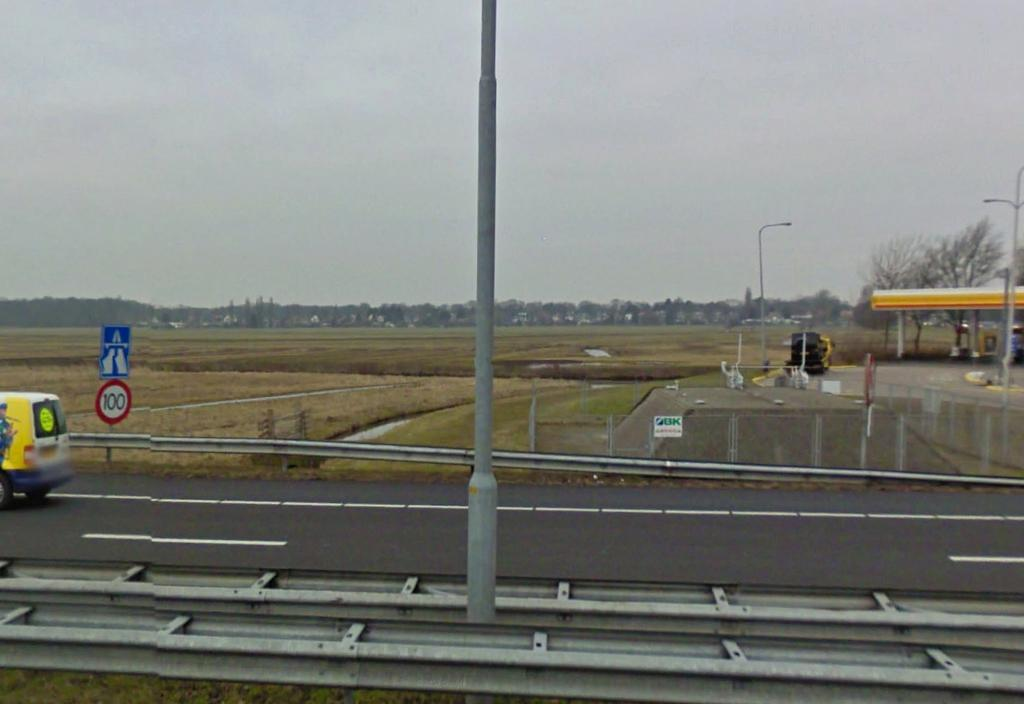What is the main feature of the image? There is a road in the image. What is on the road? There is a vehicle on the road. What can be seen in the background of the image? There are fields visible behind the road. What type of establishment is present in the image? There is a gas station in the station in the image. What is located in the middle of the image? There is a pole in the middle of the image. What type of boats are visible in the image? There are no boats present in the image; it features a road, a vehicle, fields, a gas station, and a pole. What genre of fiction is being depicted in the image? The image is not a depiction of fiction; it is a photograph or illustration of a real-life scene. 